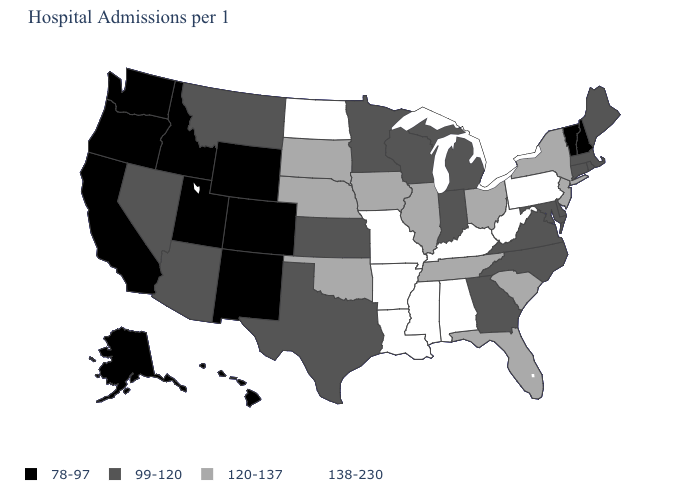Name the states that have a value in the range 138-230?
Concise answer only. Alabama, Arkansas, Kentucky, Louisiana, Mississippi, Missouri, North Dakota, Pennsylvania, West Virginia. Name the states that have a value in the range 120-137?
Be succinct. Florida, Illinois, Iowa, Nebraska, New Jersey, New York, Ohio, Oklahoma, South Carolina, South Dakota, Tennessee. What is the value of Nebraska?
Be succinct. 120-137. What is the value of New Mexico?
Concise answer only. 78-97. Name the states that have a value in the range 78-97?
Be succinct. Alaska, California, Colorado, Hawaii, Idaho, New Hampshire, New Mexico, Oregon, Utah, Vermont, Washington, Wyoming. Does Pennsylvania have the highest value in the Northeast?
Quick response, please. Yes. Name the states that have a value in the range 138-230?
Concise answer only. Alabama, Arkansas, Kentucky, Louisiana, Mississippi, Missouri, North Dakota, Pennsylvania, West Virginia. Does Kentucky have the highest value in the South?
Be succinct. Yes. Name the states that have a value in the range 120-137?
Give a very brief answer. Florida, Illinois, Iowa, Nebraska, New Jersey, New York, Ohio, Oklahoma, South Carolina, South Dakota, Tennessee. What is the highest value in states that border Wisconsin?
Write a very short answer. 120-137. Does the first symbol in the legend represent the smallest category?
Write a very short answer. Yes. Which states hav the highest value in the Northeast?
Short answer required. Pennsylvania. Does Maryland have a lower value than Wisconsin?
Answer briefly. No. Which states hav the highest value in the MidWest?
Quick response, please. Missouri, North Dakota. Name the states that have a value in the range 99-120?
Keep it brief. Arizona, Connecticut, Delaware, Georgia, Indiana, Kansas, Maine, Maryland, Massachusetts, Michigan, Minnesota, Montana, Nevada, North Carolina, Rhode Island, Texas, Virginia, Wisconsin. 